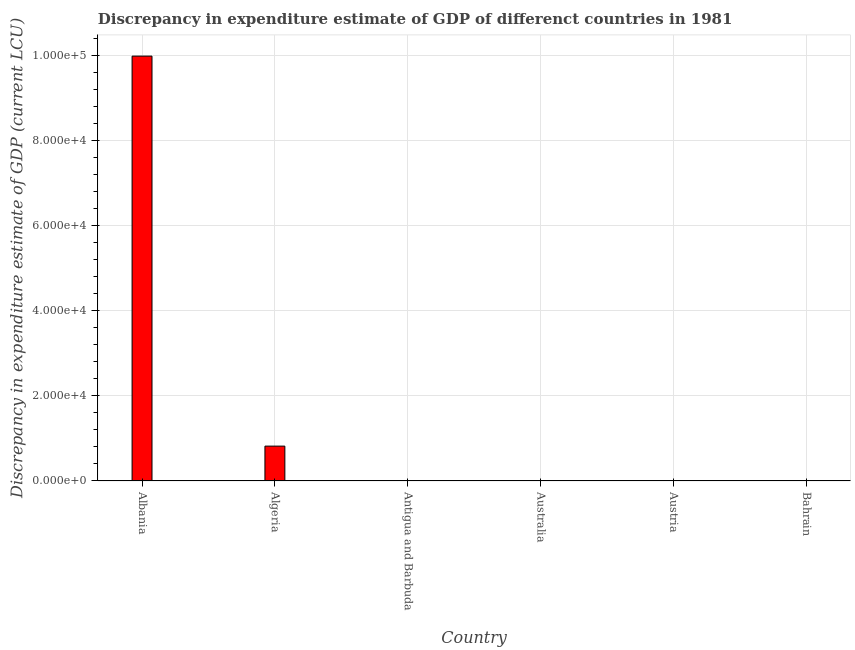Does the graph contain grids?
Offer a very short reply. Yes. What is the title of the graph?
Give a very brief answer. Discrepancy in expenditure estimate of GDP of differenct countries in 1981. What is the label or title of the Y-axis?
Keep it short and to the point. Discrepancy in expenditure estimate of GDP (current LCU). What is the discrepancy in expenditure estimate of gdp in Austria?
Your answer should be compact. 0. Across all countries, what is the maximum discrepancy in expenditure estimate of gdp?
Your response must be concise. 9.99e+04. In which country was the discrepancy in expenditure estimate of gdp maximum?
Your answer should be very brief. Albania. What is the sum of the discrepancy in expenditure estimate of gdp?
Make the answer very short. 1.08e+05. What is the average discrepancy in expenditure estimate of gdp per country?
Your response must be concise. 1.80e+04. What is the median discrepancy in expenditure estimate of gdp?
Offer a very short reply. 9.35e-8. What is the ratio of the discrepancy in expenditure estimate of gdp in Albania to that in Algeria?
Offer a terse response. 12.18. What is the difference between the highest and the second highest discrepancy in expenditure estimate of gdp?
Keep it short and to the point. 9.17e+04. What is the difference between the highest and the lowest discrepancy in expenditure estimate of gdp?
Provide a succinct answer. 9.99e+04. Are the values on the major ticks of Y-axis written in scientific E-notation?
Offer a very short reply. Yes. What is the Discrepancy in expenditure estimate of GDP (current LCU) in Albania?
Your answer should be very brief. 9.99e+04. What is the Discrepancy in expenditure estimate of GDP (current LCU) of Algeria?
Provide a short and direct response. 8200. What is the Discrepancy in expenditure estimate of GDP (current LCU) of Antigua and Barbuda?
Offer a terse response. 1.87e-7. What is the Discrepancy in expenditure estimate of GDP (current LCU) in Austria?
Provide a short and direct response. 0. What is the Discrepancy in expenditure estimate of GDP (current LCU) of Bahrain?
Your answer should be very brief. 0. What is the difference between the Discrepancy in expenditure estimate of GDP (current LCU) in Albania and Algeria?
Provide a short and direct response. 9.17e+04. What is the difference between the Discrepancy in expenditure estimate of GDP (current LCU) in Albania and Antigua and Barbuda?
Your answer should be very brief. 9.99e+04. What is the difference between the Discrepancy in expenditure estimate of GDP (current LCU) in Algeria and Antigua and Barbuda?
Ensure brevity in your answer.  8200. What is the ratio of the Discrepancy in expenditure estimate of GDP (current LCU) in Albania to that in Algeria?
Keep it short and to the point. 12.18. What is the ratio of the Discrepancy in expenditure estimate of GDP (current LCU) in Albania to that in Antigua and Barbuda?
Your answer should be very brief. 5.34e+11. What is the ratio of the Discrepancy in expenditure estimate of GDP (current LCU) in Algeria to that in Antigua and Barbuda?
Provide a short and direct response. 4.39e+1. 